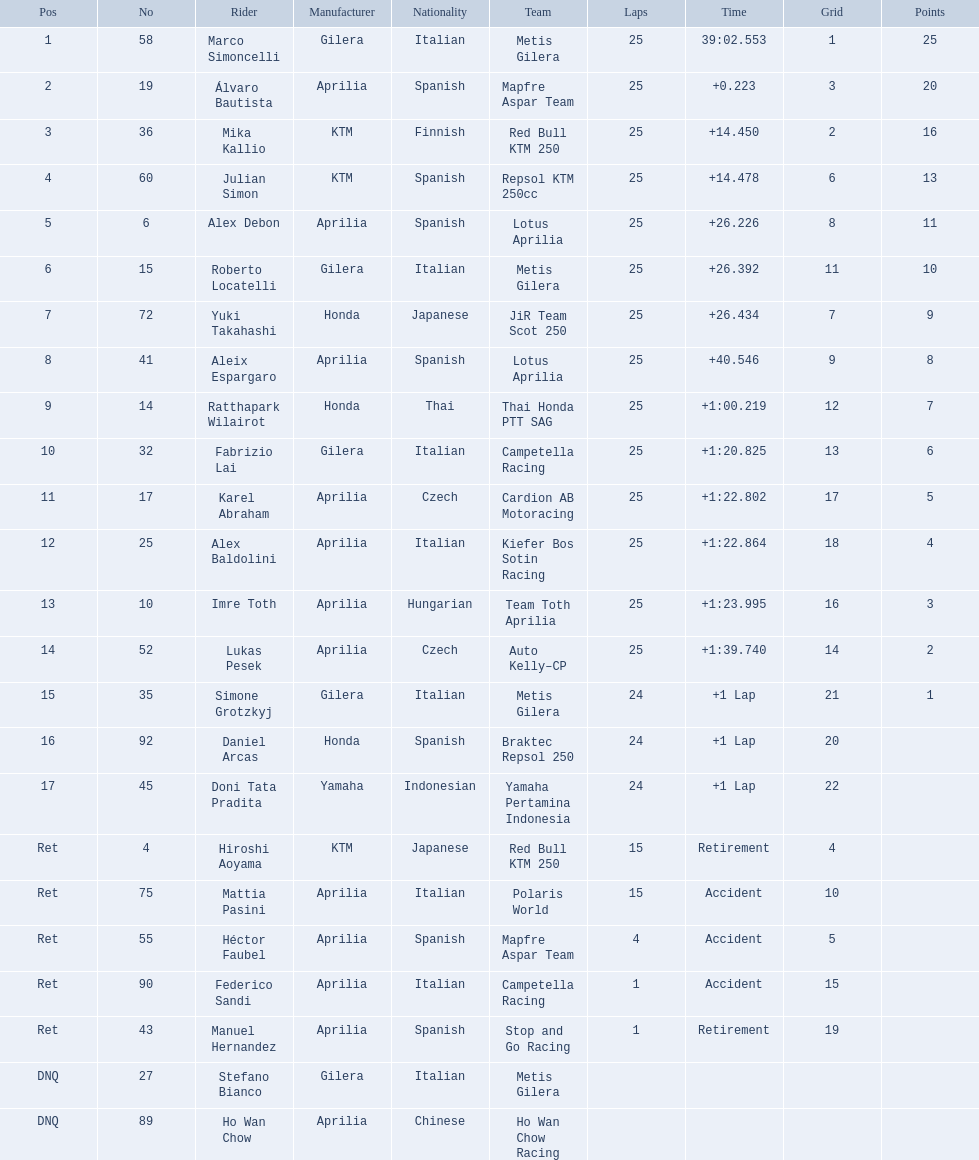Who are all the riders? Marco Simoncelli, Álvaro Bautista, Mika Kallio, Julian Simon, Alex Debon, Roberto Locatelli, Yuki Takahashi, Aleix Espargaro, Ratthapark Wilairot, Fabrizio Lai, Karel Abraham, Alex Baldolini, Imre Toth, Lukas Pesek, Simone Grotzkyj, Daniel Arcas, Doni Tata Pradita, Hiroshi Aoyama, Mattia Pasini, Héctor Faubel, Federico Sandi, Manuel Hernandez, Stefano Bianco, Ho Wan Chow. Which held rank 1? Marco Simoncelli. 